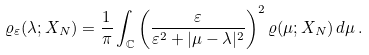Convert formula to latex. <formula><loc_0><loc_0><loc_500><loc_500>\varrho _ { \varepsilon } ( \lambda ; X _ { N } ) = \frac { 1 } { \pi } \int _ { \mathbb { C } } \left ( \frac { \varepsilon } { \varepsilon ^ { 2 } + | \mu - \lambda | ^ { 2 } } \right ) ^ { 2 } \varrho ( \mu ; X _ { N } ) \, d \mu \, .</formula> 